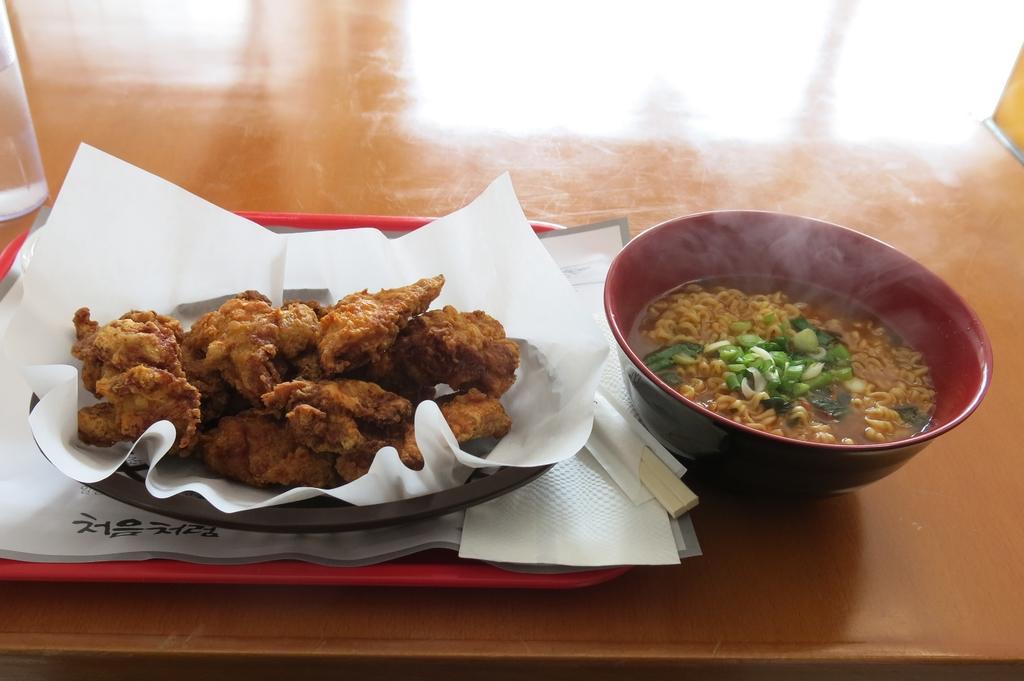Please provide a concise description of this image. In this image I can see a table and on it I can see a glass, two plates, few white colour papers, a tissue paper, two chopsticks, a bowl and different types of food. On the top right side of the image I can see a yellow colour thing on the table. 